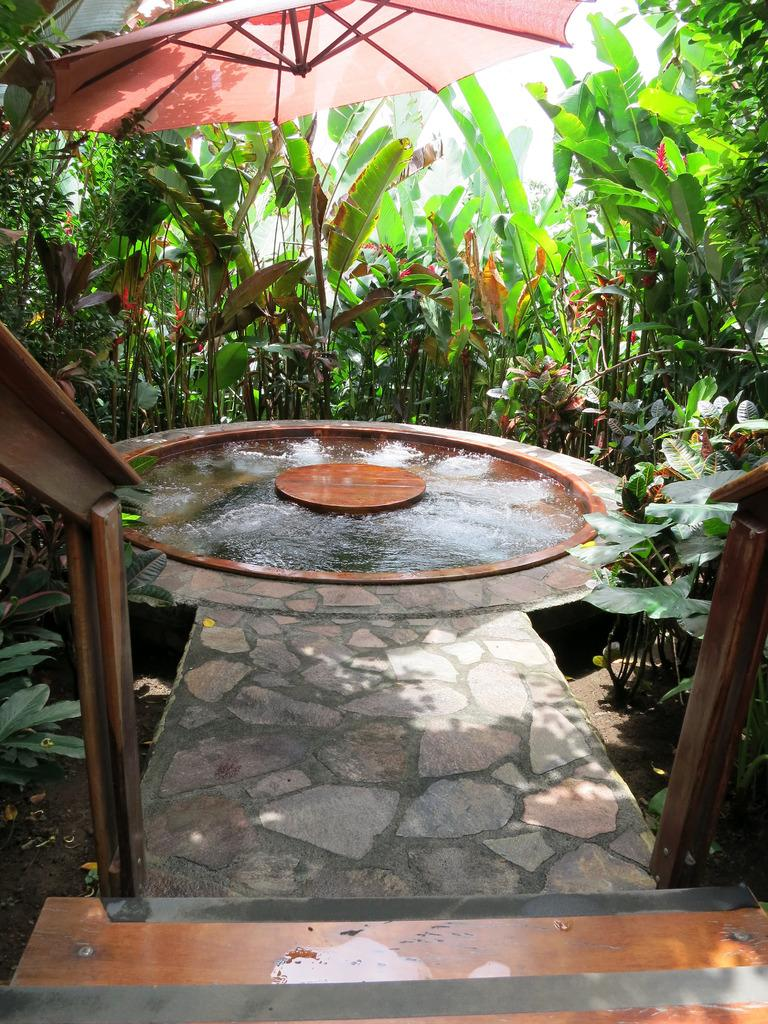What object is present in the image that can provide shelter from the rain? There is an umbrella in the image. What is the primary substance visible in the image? There is water visible in the image. What architectural feature can be seen in the image? There are steps in the image. What type of surface is present in the image for walking or traveling? There is a path in the image. What can be seen in the background of the image that provides a natural setting? There are trees in the background of the image. What type of payment is required to access the fish in the image? There are no fish present in the image, so no payment is required. What tool is used to tighten or loosen bolts in the image? There is no wrench present in the image, so it cannot be used to tighten or loosen bolts. 